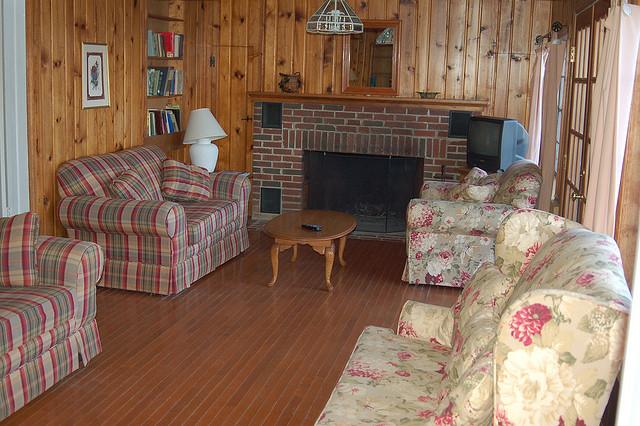How many lamps are in the room?
Keep it brief. 1. What is the fireplace made out of?
Short answer required. Brick. What kind of room is this called?
Concise answer only. Living room. 